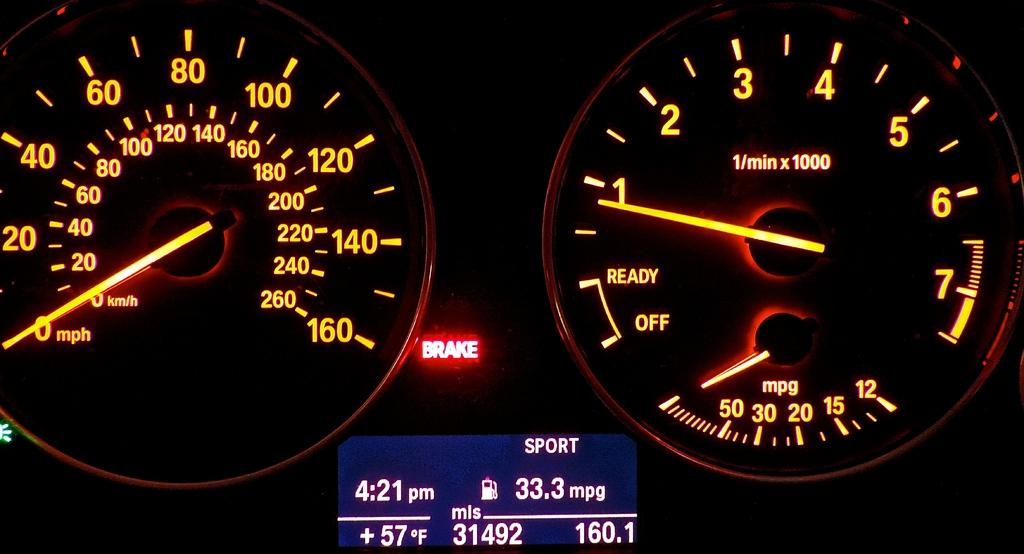<image>
Present a compact description of the photo's key features. The speedometer and mpg gauges of a vehicle with the words Brake lighting up in red. 